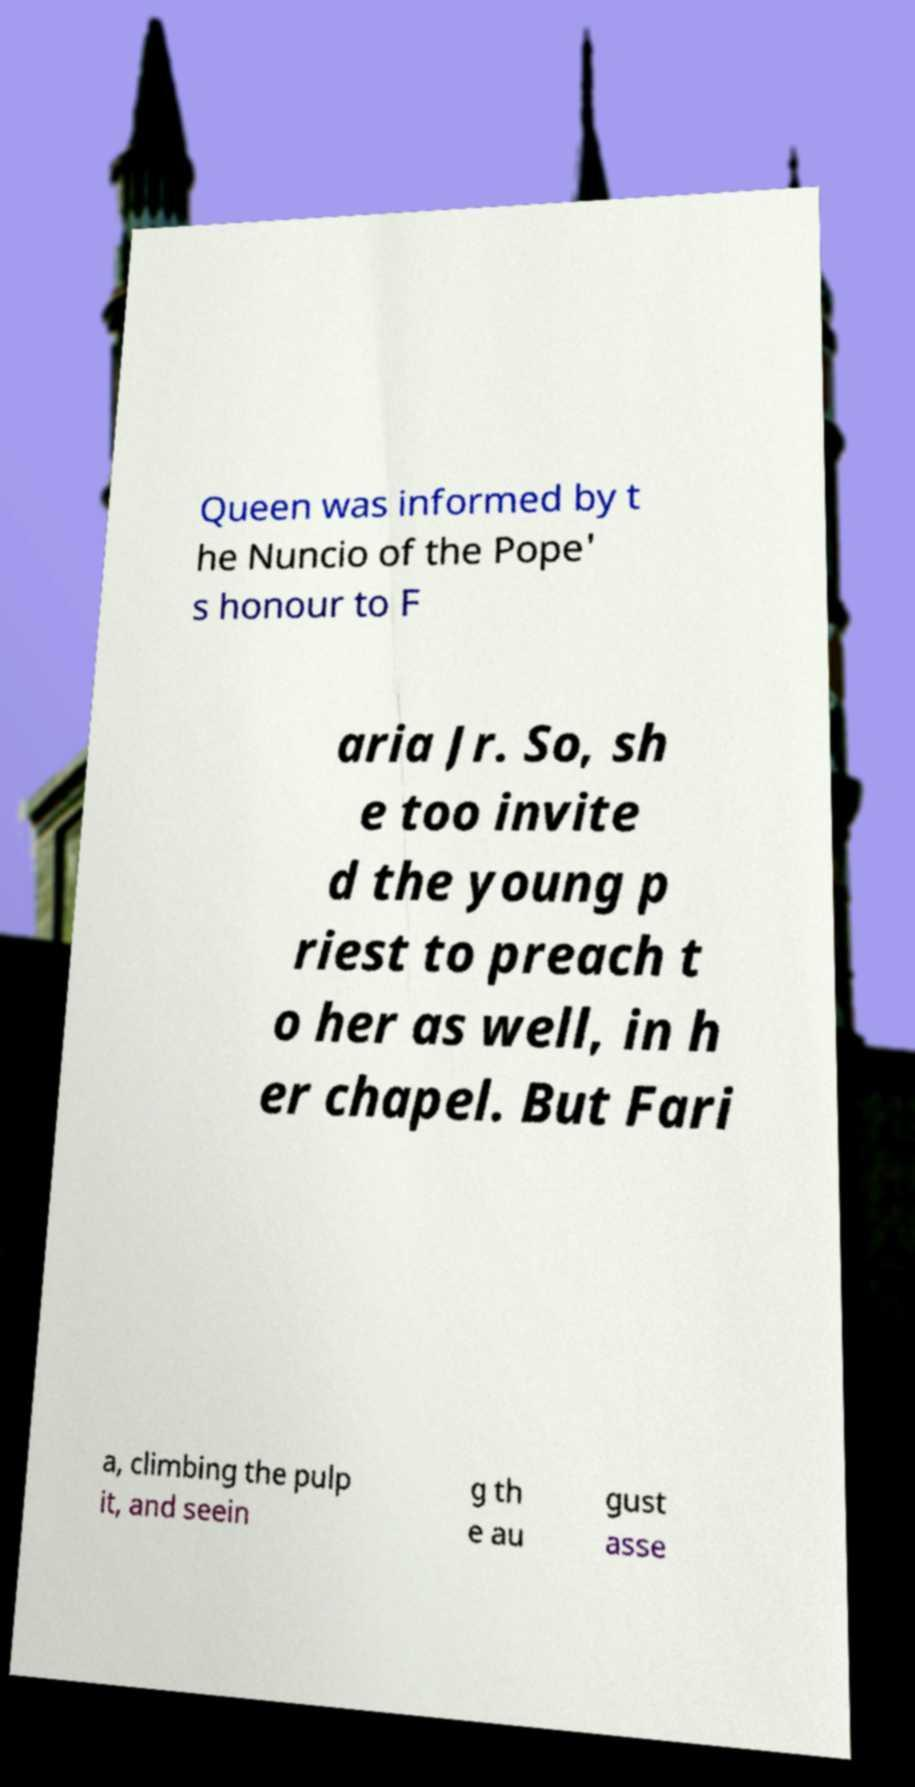Please identify and transcribe the text found in this image. Queen was informed by t he Nuncio of the Pope' s honour to F aria Jr. So, sh e too invite d the young p riest to preach t o her as well, in h er chapel. But Fari a, climbing the pulp it, and seein g th e au gust asse 